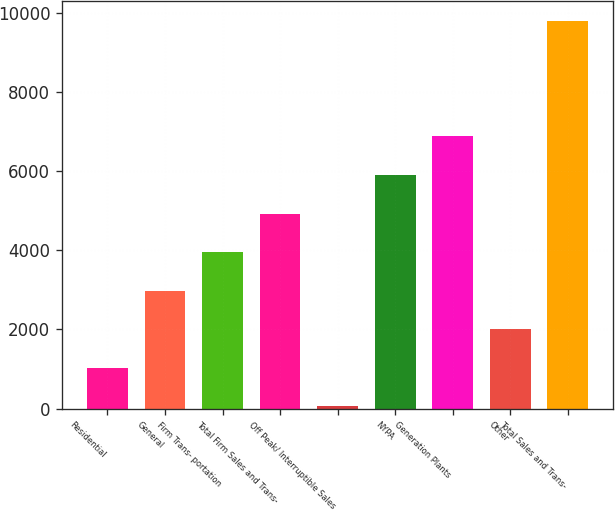<chart> <loc_0><loc_0><loc_500><loc_500><bar_chart><fcel>Residential<fcel>General<fcel>Firm Trans- portation<fcel>Total Firm Sales and Trans-<fcel>Off Peak/ Interruptible Sales<fcel>NYPA<fcel>Generation Plants<fcel>Other<fcel>Total Sales and Trans-<nl><fcel>1032.7<fcel>2980.1<fcel>3953.8<fcel>4927.5<fcel>59<fcel>5901.2<fcel>6874.9<fcel>2006.4<fcel>9796<nl></chart> 